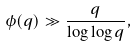Convert formula to latex. <formula><loc_0><loc_0><loc_500><loc_500>\phi ( q ) \gg \frac { q } { \log \log q } ,</formula> 